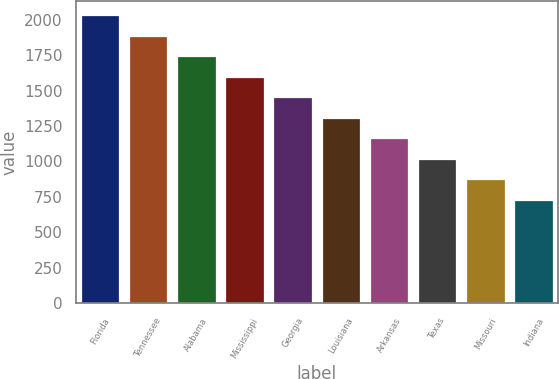Convert chart to OTSL. <chart><loc_0><loc_0><loc_500><loc_500><bar_chart><fcel>Florida<fcel>Tennessee<fcel>Alabama<fcel>Mississippi<fcel>Georgia<fcel>Louisiana<fcel>Arkansas<fcel>Texas<fcel>Missouri<fcel>Indiana<nl><fcel>2032.8<fcel>1888.1<fcel>1743.4<fcel>1598.7<fcel>1454<fcel>1309.3<fcel>1164.6<fcel>1019.9<fcel>875.2<fcel>730.5<nl></chart> 